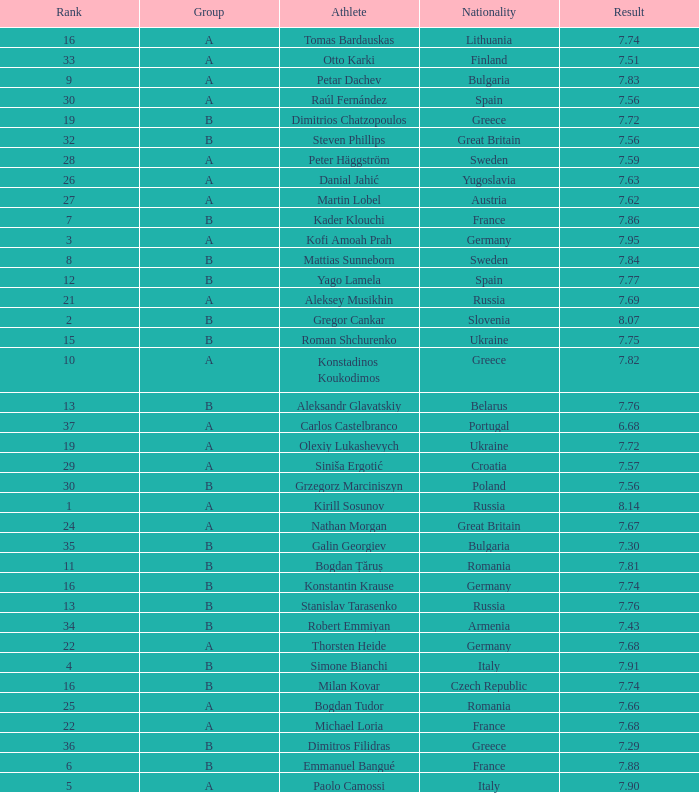Which athlete's rank is more than 15 when the result is less than 7.68, the group is b, and the nationality listed is Great Britain? Steven Phillips. 